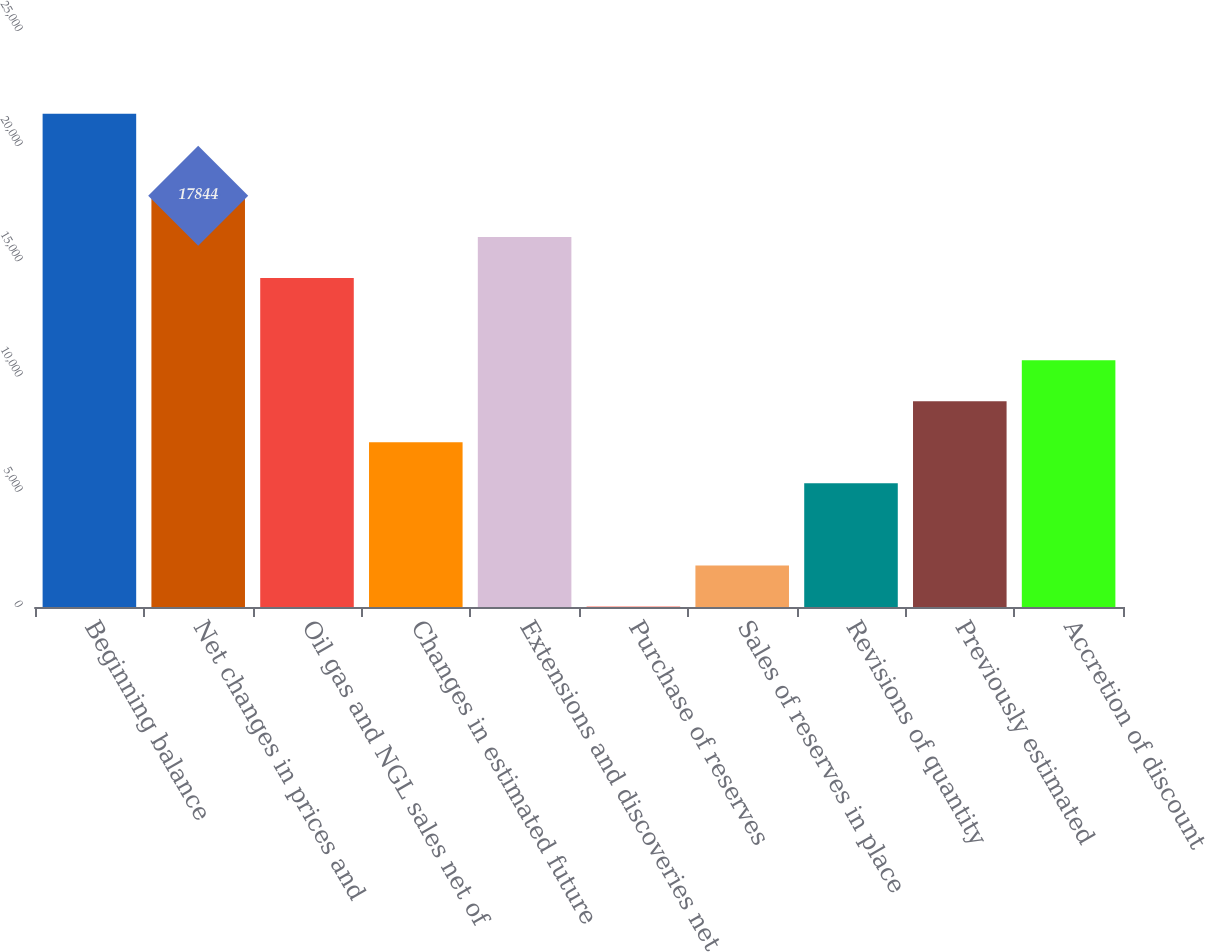Convert chart. <chart><loc_0><loc_0><loc_500><loc_500><bar_chart><fcel>Beginning balance<fcel>Net changes in prices and<fcel>Oil gas and NGL sales net of<fcel>Changes in estimated future<fcel>Extensions and discoveries net<fcel>Purchase of reserves<fcel>Sales of reserves in place<fcel>Revisions of quantity<fcel>Previously estimated<fcel>Accretion of discount<nl><fcel>21409.2<fcel>17844<fcel>14278.8<fcel>7148.4<fcel>16061.4<fcel>18<fcel>1800.6<fcel>5365.8<fcel>8931<fcel>10713.6<nl></chart> 